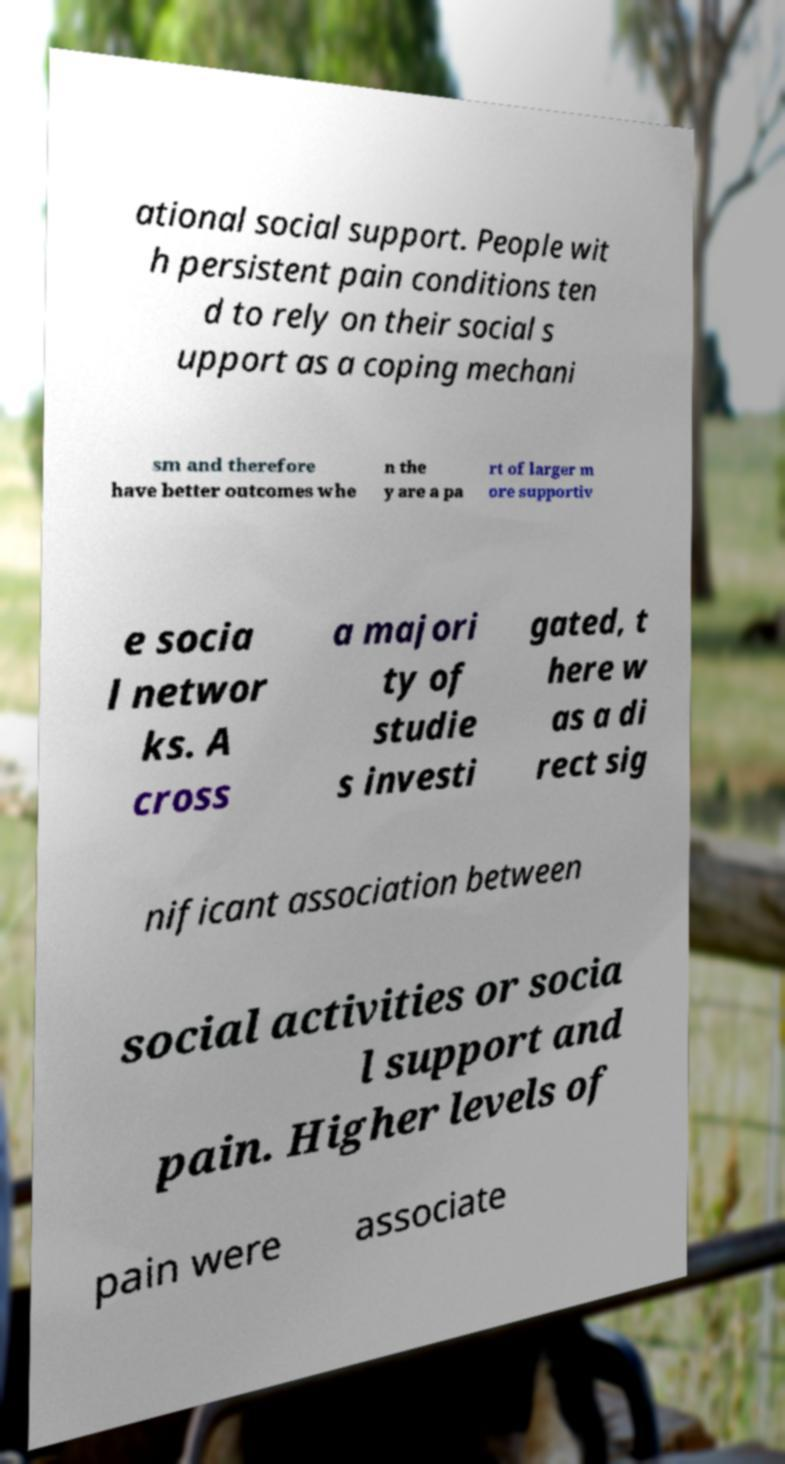Please read and relay the text visible in this image. What does it say? ational social support. People wit h persistent pain conditions ten d to rely on their social s upport as a coping mechani sm and therefore have better outcomes whe n the y are a pa rt of larger m ore supportiv e socia l networ ks. A cross a majori ty of studie s investi gated, t here w as a di rect sig nificant association between social activities or socia l support and pain. Higher levels of pain were associate 